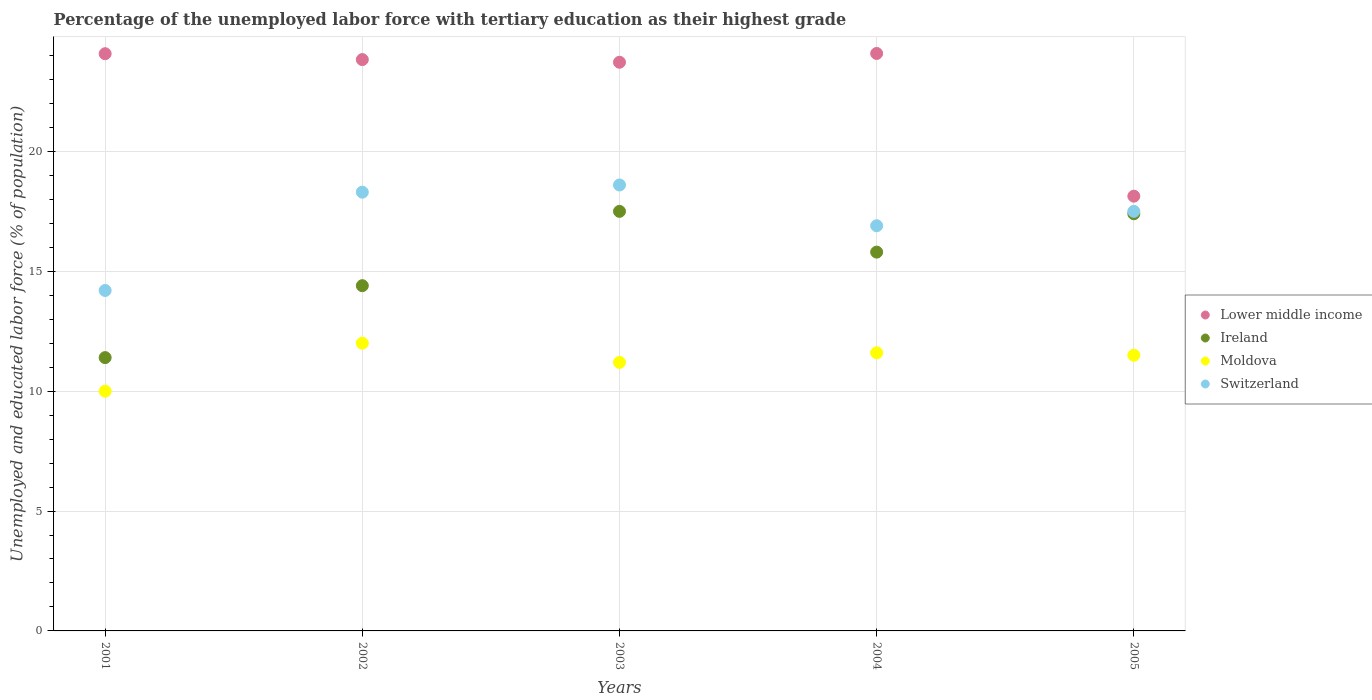How many different coloured dotlines are there?
Ensure brevity in your answer.  4. Is the number of dotlines equal to the number of legend labels?
Ensure brevity in your answer.  Yes. What is the percentage of the unemployed labor force with tertiary education in Lower middle income in 2002?
Provide a succinct answer. 23.83. Across all years, what is the maximum percentage of the unemployed labor force with tertiary education in Lower middle income?
Provide a succinct answer. 24.09. Across all years, what is the minimum percentage of the unemployed labor force with tertiary education in Lower middle income?
Your response must be concise. 18.13. In which year was the percentage of the unemployed labor force with tertiary education in Switzerland maximum?
Make the answer very short. 2003. In which year was the percentage of the unemployed labor force with tertiary education in Ireland minimum?
Your response must be concise. 2001. What is the total percentage of the unemployed labor force with tertiary education in Moldova in the graph?
Offer a very short reply. 56.3. What is the difference between the percentage of the unemployed labor force with tertiary education in Ireland in 2001 and that in 2005?
Ensure brevity in your answer.  -6. What is the difference between the percentage of the unemployed labor force with tertiary education in Moldova in 2001 and the percentage of the unemployed labor force with tertiary education in Ireland in 2005?
Offer a terse response. -7.4. What is the average percentage of the unemployed labor force with tertiary education in Switzerland per year?
Your answer should be very brief. 17.1. In the year 2002, what is the difference between the percentage of the unemployed labor force with tertiary education in Lower middle income and percentage of the unemployed labor force with tertiary education in Switzerland?
Your answer should be very brief. 5.53. What is the ratio of the percentage of the unemployed labor force with tertiary education in Switzerland in 2002 to that in 2004?
Make the answer very short. 1.08. What is the difference between the highest and the second highest percentage of the unemployed labor force with tertiary education in Moldova?
Make the answer very short. 0.4. What is the difference between the highest and the lowest percentage of the unemployed labor force with tertiary education in Switzerland?
Provide a succinct answer. 4.4. In how many years, is the percentage of the unemployed labor force with tertiary education in Lower middle income greater than the average percentage of the unemployed labor force with tertiary education in Lower middle income taken over all years?
Give a very brief answer. 4. Is the sum of the percentage of the unemployed labor force with tertiary education in Moldova in 2001 and 2005 greater than the maximum percentage of the unemployed labor force with tertiary education in Ireland across all years?
Provide a succinct answer. Yes. Is it the case that in every year, the sum of the percentage of the unemployed labor force with tertiary education in Lower middle income and percentage of the unemployed labor force with tertiary education in Switzerland  is greater than the sum of percentage of the unemployed labor force with tertiary education in Ireland and percentage of the unemployed labor force with tertiary education in Moldova?
Make the answer very short. Yes. What is the difference between two consecutive major ticks on the Y-axis?
Offer a very short reply. 5. Where does the legend appear in the graph?
Keep it short and to the point. Center right. How many legend labels are there?
Your answer should be compact. 4. How are the legend labels stacked?
Make the answer very short. Vertical. What is the title of the graph?
Give a very brief answer. Percentage of the unemployed labor force with tertiary education as their highest grade. What is the label or title of the Y-axis?
Offer a terse response. Unemployed and educated labor force (% of population). What is the Unemployed and educated labor force (% of population) of Lower middle income in 2001?
Keep it short and to the point. 24.08. What is the Unemployed and educated labor force (% of population) in Ireland in 2001?
Keep it short and to the point. 11.4. What is the Unemployed and educated labor force (% of population) in Switzerland in 2001?
Your answer should be compact. 14.2. What is the Unemployed and educated labor force (% of population) in Lower middle income in 2002?
Provide a short and direct response. 23.83. What is the Unemployed and educated labor force (% of population) of Ireland in 2002?
Keep it short and to the point. 14.4. What is the Unemployed and educated labor force (% of population) in Moldova in 2002?
Make the answer very short. 12. What is the Unemployed and educated labor force (% of population) of Switzerland in 2002?
Your response must be concise. 18.3. What is the Unemployed and educated labor force (% of population) in Lower middle income in 2003?
Ensure brevity in your answer.  23.72. What is the Unemployed and educated labor force (% of population) of Moldova in 2003?
Your answer should be compact. 11.2. What is the Unemployed and educated labor force (% of population) in Switzerland in 2003?
Your response must be concise. 18.6. What is the Unemployed and educated labor force (% of population) of Lower middle income in 2004?
Give a very brief answer. 24.09. What is the Unemployed and educated labor force (% of population) of Ireland in 2004?
Ensure brevity in your answer.  15.8. What is the Unemployed and educated labor force (% of population) of Moldova in 2004?
Your answer should be very brief. 11.6. What is the Unemployed and educated labor force (% of population) in Switzerland in 2004?
Offer a terse response. 16.9. What is the Unemployed and educated labor force (% of population) of Lower middle income in 2005?
Your answer should be compact. 18.13. What is the Unemployed and educated labor force (% of population) in Ireland in 2005?
Ensure brevity in your answer.  17.4. What is the Unemployed and educated labor force (% of population) in Moldova in 2005?
Make the answer very short. 11.5. What is the Unemployed and educated labor force (% of population) of Switzerland in 2005?
Keep it short and to the point. 17.5. Across all years, what is the maximum Unemployed and educated labor force (% of population) of Lower middle income?
Offer a terse response. 24.09. Across all years, what is the maximum Unemployed and educated labor force (% of population) of Moldova?
Your response must be concise. 12. Across all years, what is the maximum Unemployed and educated labor force (% of population) in Switzerland?
Provide a short and direct response. 18.6. Across all years, what is the minimum Unemployed and educated labor force (% of population) of Lower middle income?
Your answer should be very brief. 18.13. Across all years, what is the minimum Unemployed and educated labor force (% of population) of Ireland?
Your answer should be very brief. 11.4. Across all years, what is the minimum Unemployed and educated labor force (% of population) of Moldova?
Provide a succinct answer. 10. Across all years, what is the minimum Unemployed and educated labor force (% of population) of Switzerland?
Your answer should be compact. 14.2. What is the total Unemployed and educated labor force (% of population) in Lower middle income in the graph?
Keep it short and to the point. 113.84. What is the total Unemployed and educated labor force (% of population) in Ireland in the graph?
Ensure brevity in your answer.  76.5. What is the total Unemployed and educated labor force (% of population) in Moldova in the graph?
Provide a succinct answer. 56.3. What is the total Unemployed and educated labor force (% of population) in Switzerland in the graph?
Provide a short and direct response. 85.5. What is the difference between the Unemployed and educated labor force (% of population) in Lower middle income in 2001 and that in 2002?
Provide a succinct answer. 0.25. What is the difference between the Unemployed and educated labor force (% of population) in Moldova in 2001 and that in 2002?
Offer a very short reply. -2. What is the difference between the Unemployed and educated labor force (% of population) in Switzerland in 2001 and that in 2002?
Your answer should be compact. -4.1. What is the difference between the Unemployed and educated labor force (% of population) of Lower middle income in 2001 and that in 2003?
Give a very brief answer. 0.36. What is the difference between the Unemployed and educated labor force (% of population) of Ireland in 2001 and that in 2003?
Give a very brief answer. -6.1. What is the difference between the Unemployed and educated labor force (% of population) in Lower middle income in 2001 and that in 2004?
Ensure brevity in your answer.  -0.01. What is the difference between the Unemployed and educated labor force (% of population) of Moldova in 2001 and that in 2004?
Your answer should be compact. -1.6. What is the difference between the Unemployed and educated labor force (% of population) in Lower middle income in 2001 and that in 2005?
Your answer should be compact. 5.94. What is the difference between the Unemployed and educated labor force (% of population) in Ireland in 2001 and that in 2005?
Give a very brief answer. -6. What is the difference between the Unemployed and educated labor force (% of population) of Moldova in 2001 and that in 2005?
Your response must be concise. -1.5. What is the difference between the Unemployed and educated labor force (% of population) in Switzerland in 2001 and that in 2005?
Your response must be concise. -3.3. What is the difference between the Unemployed and educated labor force (% of population) of Lower middle income in 2002 and that in 2003?
Provide a short and direct response. 0.11. What is the difference between the Unemployed and educated labor force (% of population) of Ireland in 2002 and that in 2003?
Ensure brevity in your answer.  -3.1. What is the difference between the Unemployed and educated labor force (% of population) in Lower middle income in 2002 and that in 2004?
Give a very brief answer. -0.26. What is the difference between the Unemployed and educated labor force (% of population) in Ireland in 2002 and that in 2004?
Provide a short and direct response. -1.4. What is the difference between the Unemployed and educated labor force (% of population) of Moldova in 2002 and that in 2004?
Make the answer very short. 0.4. What is the difference between the Unemployed and educated labor force (% of population) of Lower middle income in 2002 and that in 2005?
Make the answer very short. 5.7. What is the difference between the Unemployed and educated labor force (% of population) in Switzerland in 2002 and that in 2005?
Offer a very short reply. 0.8. What is the difference between the Unemployed and educated labor force (% of population) in Lower middle income in 2003 and that in 2004?
Your answer should be very brief. -0.37. What is the difference between the Unemployed and educated labor force (% of population) of Ireland in 2003 and that in 2004?
Offer a terse response. 1.7. What is the difference between the Unemployed and educated labor force (% of population) of Moldova in 2003 and that in 2004?
Provide a short and direct response. -0.4. What is the difference between the Unemployed and educated labor force (% of population) in Lower middle income in 2003 and that in 2005?
Make the answer very short. 5.59. What is the difference between the Unemployed and educated labor force (% of population) in Moldova in 2003 and that in 2005?
Ensure brevity in your answer.  -0.3. What is the difference between the Unemployed and educated labor force (% of population) of Lower middle income in 2004 and that in 2005?
Give a very brief answer. 5.95. What is the difference between the Unemployed and educated labor force (% of population) of Moldova in 2004 and that in 2005?
Offer a very short reply. 0.1. What is the difference between the Unemployed and educated labor force (% of population) in Lower middle income in 2001 and the Unemployed and educated labor force (% of population) in Ireland in 2002?
Offer a very short reply. 9.68. What is the difference between the Unemployed and educated labor force (% of population) in Lower middle income in 2001 and the Unemployed and educated labor force (% of population) in Moldova in 2002?
Make the answer very short. 12.08. What is the difference between the Unemployed and educated labor force (% of population) in Lower middle income in 2001 and the Unemployed and educated labor force (% of population) in Switzerland in 2002?
Make the answer very short. 5.78. What is the difference between the Unemployed and educated labor force (% of population) of Ireland in 2001 and the Unemployed and educated labor force (% of population) of Moldova in 2002?
Ensure brevity in your answer.  -0.6. What is the difference between the Unemployed and educated labor force (% of population) in Ireland in 2001 and the Unemployed and educated labor force (% of population) in Switzerland in 2002?
Offer a terse response. -6.9. What is the difference between the Unemployed and educated labor force (% of population) in Moldova in 2001 and the Unemployed and educated labor force (% of population) in Switzerland in 2002?
Ensure brevity in your answer.  -8.3. What is the difference between the Unemployed and educated labor force (% of population) of Lower middle income in 2001 and the Unemployed and educated labor force (% of population) of Ireland in 2003?
Provide a short and direct response. 6.58. What is the difference between the Unemployed and educated labor force (% of population) of Lower middle income in 2001 and the Unemployed and educated labor force (% of population) of Moldova in 2003?
Your response must be concise. 12.88. What is the difference between the Unemployed and educated labor force (% of population) in Lower middle income in 2001 and the Unemployed and educated labor force (% of population) in Switzerland in 2003?
Provide a succinct answer. 5.48. What is the difference between the Unemployed and educated labor force (% of population) of Ireland in 2001 and the Unemployed and educated labor force (% of population) of Switzerland in 2003?
Give a very brief answer. -7.2. What is the difference between the Unemployed and educated labor force (% of population) of Moldova in 2001 and the Unemployed and educated labor force (% of population) of Switzerland in 2003?
Give a very brief answer. -8.6. What is the difference between the Unemployed and educated labor force (% of population) in Lower middle income in 2001 and the Unemployed and educated labor force (% of population) in Ireland in 2004?
Make the answer very short. 8.28. What is the difference between the Unemployed and educated labor force (% of population) in Lower middle income in 2001 and the Unemployed and educated labor force (% of population) in Moldova in 2004?
Offer a very short reply. 12.48. What is the difference between the Unemployed and educated labor force (% of population) of Lower middle income in 2001 and the Unemployed and educated labor force (% of population) of Switzerland in 2004?
Provide a short and direct response. 7.18. What is the difference between the Unemployed and educated labor force (% of population) in Moldova in 2001 and the Unemployed and educated labor force (% of population) in Switzerland in 2004?
Your answer should be very brief. -6.9. What is the difference between the Unemployed and educated labor force (% of population) in Lower middle income in 2001 and the Unemployed and educated labor force (% of population) in Ireland in 2005?
Keep it short and to the point. 6.68. What is the difference between the Unemployed and educated labor force (% of population) in Lower middle income in 2001 and the Unemployed and educated labor force (% of population) in Moldova in 2005?
Provide a succinct answer. 12.58. What is the difference between the Unemployed and educated labor force (% of population) of Lower middle income in 2001 and the Unemployed and educated labor force (% of population) of Switzerland in 2005?
Your response must be concise. 6.58. What is the difference between the Unemployed and educated labor force (% of population) of Ireland in 2001 and the Unemployed and educated labor force (% of population) of Switzerland in 2005?
Ensure brevity in your answer.  -6.1. What is the difference between the Unemployed and educated labor force (% of population) in Moldova in 2001 and the Unemployed and educated labor force (% of population) in Switzerland in 2005?
Make the answer very short. -7.5. What is the difference between the Unemployed and educated labor force (% of population) in Lower middle income in 2002 and the Unemployed and educated labor force (% of population) in Ireland in 2003?
Offer a very short reply. 6.33. What is the difference between the Unemployed and educated labor force (% of population) of Lower middle income in 2002 and the Unemployed and educated labor force (% of population) of Moldova in 2003?
Provide a short and direct response. 12.63. What is the difference between the Unemployed and educated labor force (% of population) in Lower middle income in 2002 and the Unemployed and educated labor force (% of population) in Switzerland in 2003?
Your answer should be compact. 5.23. What is the difference between the Unemployed and educated labor force (% of population) of Ireland in 2002 and the Unemployed and educated labor force (% of population) of Moldova in 2003?
Your answer should be compact. 3.2. What is the difference between the Unemployed and educated labor force (% of population) of Ireland in 2002 and the Unemployed and educated labor force (% of population) of Switzerland in 2003?
Offer a terse response. -4.2. What is the difference between the Unemployed and educated labor force (% of population) in Moldova in 2002 and the Unemployed and educated labor force (% of population) in Switzerland in 2003?
Ensure brevity in your answer.  -6.6. What is the difference between the Unemployed and educated labor force (% of population) in Lower middle income in 2002 and the Unemployed and educated labor force (% of population) in Ireland in 2004?
Ensure brevity in your answer.  8.03. What is the difference between the Unemployed and educated labor force (% of population) of Lower middle income in 2002 and the Unemployed and educated labor force (% of population) of Moldova in 2004?
Your response must be concise. 12.23. What is the difference between the Unemployed and educated labor force (% of population) in Lower middle income in 2002 and the Unemployed and educated labor force (% of population) in Switzerland in 2004?
Your answer should be compact. 6.93. What is the difference between the Unemployed and educated labor force (% of population) of Lower middle income in 2002 and the Unemployed and educated labor force (% of population) of Ireland in 2005?
Offer a terse response. 6.43. What is the difference between the Unemployed and educated labor force (% of population) of Lower middle income in 2002 and the Unemployed and educated labor force (% of population) of Moldova in 2005?
Provide a short and direct response. 12.33. What is the difference between the Unemployed and educated labor force (% of population) of Lower middle income in 2002 and the Unemployed and educated labor force (% of population) of Switzerland in 2005?
Offer a terse response. 6.33. What is the difference between the Unemployed and educated labor force (% of population) of Ireland in 2002 and the Unemployed and educated labor force (% of population) of Moldova in 2005?
Offer a very short reply. 2.9. What is the difference between the Unemployed and educated labor force (% of population) in Lower middle income in 2003 and the Unemployed and educated labor force (% of population) in Ireland in 2004?
Make the answer very short. 7.92. What is the difference between the Unemployed and educated labor force (% of population) of Lower middle income in 2003 and the Unemployed and educated labor force (% of population) of Moldova in 2004?
Your answer should be very brief. 12.12. What is the difference between the Unemployed and educated labor force (% of population) in Lower middle income in 2003 and the Unemployed and educated labor force (% of population) in Switzerland in 2004?
Your answer should be compact. 6.82. What is the difference between the Unemployed and educated labor force (% of population) in Ireland in 2003 and the Unemployed and educated labor force (% of population) in Moldova in 2004?
Keep it short and to the point. 5.9. What is the difference between the Unemployed and educated labor force (% of population) in Ireland in 2003 and the Unemployed and educated labor force (% of population) in Switzerland in 2004?
Make the answer very short. 0.6. What is the difference between the Unemployed and educated labor force (% of population) in Lower middle income in 2003 and the Unemployed and educated labor force (% of population) in Ireland in 2005?
Your answer should be very brief. 6.32. What is the difference between the Unemployed and educated labor force (% of population) in Lower middle income in 2003 and the Unemployed and educated labor force (% of population) in Moldova in 2005?
Your answer should be compact. 12.22. What is the difference between the Unemployed and educated labor force (% of population) of Lower middle income in 2003 and the Unemployed and educated labor force (% of population) of Switzerland in 2005?
Your answer should be compact. 6.22. What is the difference between the Unemployed and educated labor force (% of population) in Lower middle income in 2004 and the Unemployed and educated labor force (% of population) in Ireland in 2005?
Offer a terse response. 6.69. What is the difference between the Unemployed and educated labor force (% of population) of Lower middle income in 2004 and the Unemployed and educated labor force (% of population) of Moldova in 2005?
Provide a succinct answer. 12.59. What is the difference between the Unemployed and educated labor force (% of population) in Lower middle income in 2004 and the Unemployed and educated labor force (% of population) in Switzerland in 2005?
Your answer should be compact. 6.59. What is the difference between the Unemployed and educated labor force (% of population) in Ireland in 2004 and the Unemployed and educated labor force (% of population) in Moldova in 2005?
Make the answer very short. 4.3. What is the difference between the Unemployed and educated labor force (% of population) of Moldova in 2004 and the Unemployed and educated labor force (% of population) of Switzerland in 2005?
Provide a short and direct response. -5.9. What is the average Unemployed and educated labor force (% of population) in Lower middle income per year?
Keep it short and to the point. 22.77. What is the average Unemployed and educated labor force (% of population) of Moldova per year?
Your response must be concise. 11.26. In the year 2001, what is the difference between the Unemployed and educated labor force (% of population) of Lower middle income and Unemployed and educated labor force (% of population) of Ireland?
Offer a very short reply. 12.68. In the year 2001, what is the difference between the Unemployed and educated labor force (% of population) in Lower middle income and Unemployed and educated labor force (% of population) in Moldova?
Give a very brief answer. 14.08. In the year 2001, what is the difference between the Unemployed and educated labor force (% of population) of Lower middle income and Unemployed and educated labor force (% of population) of Switzerland?
Make the answer very short. 9.88. In the year 2001, what is the difference between the Unemployed and educated labor force (% of population) in Ireland and Unemployed and educated labor force (% of population) in Moldova?
Provide a short and direct response. 1.4. In the year 2002, what is the difference between the Unemployed and educated labor force (% of population) in Lower middle income and Unemployed and educated labor force (% of population) in Ireland?
Keep it short and to the point. 9.43. In the year 2002, what is the difference between the Unemployed and educated labor force (% of population) of Lower middle income and Unemployed and educated labor force (% of population) of Moldova?
Give a very brief answer. 11.83. In the year 2002, what is the difference between the Unemployed and educated labor force (% of population) of Lower middle income and Unemployed and educated labor force (% of population) of Switzerland?
Provide a succinct answer. 5.53. In the year 2002, what is the difference between the Unemployed and educated labor force (% of population) in Ireland and Unemployed and educated labor force (% of population) in Moldova?
Provide a succinct answer. 2.4. In the year 2003, what is the difference between the Unemployed and educated labor force (% of population) of Lower middle income and Unemployed and educated labor force (% of population) of Ireland?
Keep it short and to the point. 6.22. In the year 2003, what is the difference between the Unemployed and educated labor force (% of population) of Lower middle income and Unemployed and educated labor force (% of population) of Moldova?
Your answer should be very brief. 12.52. In the year 2003, what is the difference between the Unemployed and educated labor force (% of population) of Lower middle income and Unemployed and educated labor force (% of population) of Switzerland?
Ensure brevity in your answer.  5.12. In the year 2003, what is the difference between the Unemployed and educated labor force (% of population) in Ireland and Unemployed and educated labor force (% of population) in Moldova?
Make the answer very short. 6.3. In the year 2004, what is the difference between the Unemployed and educated labor force (% of population) of Lower middle income and Unemployed and educated labor force (% of population) of Ireland?
Your answer should be very brief. 8.29. In the year 2004, what is the difference between the Unemployed and educated labor force (% of population) of Lower middle income and Unemployed and educated labor force (% of population) of Moldova?
Offer a terse response. 12.49. In the year 2004, what is the difference between the Unemployed and educated labor force (% of population) of Lower middle income and Unemployed and educated labor force (% of population) of Switzerland?
Keep it short and to the point. 7.19. In the year 2004, what is the difference between the Unemployed and educated labor force (% of population) in Ireland and Unemployed and educated labor force (% of population) in Switzerland?
Offer a terse response. -1.1. In the year 2004, what is the difference between the Unemployed and educated labor force (% of population) in Moldova and Unemployed and educated labor force (% of population) in Switzerland?
Provide a short and direct response. -5.3. In the year 2005, what is the difference between the Unemployed and educated labor force (% of population) in Lower middle income and Unemployed and educated labor force (% of population) in Ireland?
Your answer should be compact. 0.73. In the year 2005, what is the difference between the Unemployed and educated labor force (% of population) of Lower middle income and Unemployed and educated labor force (% of population) of Moldova?
Your answer should be very brief. 6.63. In the year 2005, what is the difference between the Unemployed and educated labor force (% of population) of Lower middle income and Unemployed and educated labor force (% of population) of Switzerland?
Keep it short and to the point. 0.63. In the year 2005, what is the difference between the Unemployed and educated labor force (% of population) of Ireland and Unemployed and educated labor force (% of population) of Switzerland?
Your answer should be very brief. -0.1. In the year 2005, what is the difference between the Unemployed and educated labor force (% of population) of Moldova and Unemployed and educated labor force (% of population) of Switzerland?
Offer a terse response. -6. What is the ratio of the Unemployed and educated labor force (% of population) in Lower middle income in 2001 to that in 2002?
Provide a short and direct response. 1.01. What is the ratio of the Unemployed and educated labor force (% of population) in Ireland in 2001 to that in 2002?
Provide a succinct answer. 0.79. What is the ratio of the Unemployed and educated labor force (% of population) in Switzerland in 2001 to that in 2002?
Offer a terse response. 0.78. What is the ratio of the Unemployed and educated labor force (% of population) in Ireland in 2001 to that in 2003?
Offer a very short reply. 0.65. What is the ratio of the Unemployed and educated labor force (% of population) of Moldova in 2001 to that in 2003?
Keep it short and to the point. 0.89. What is the ratio of the Unemployed and educated labor force (% of population) of Switzerland in 2001 to that in 2003?
Give a very brief answer. 0.76. What is the ratio of the Unemployed and educated labor force (% of population) in Lower middle income in 2001 to that in 2004?
Provide a short and direct response. 1. What is the ratio of the Unemployed and educated labor force (% of population) of Ireland in 2001 to that in 2004?
Give a very brief answer. 0.72. What is the ratio of the Unemployed and educated labor force (% of population) in Moldova in 2001 to that in 2004?
Keep it short and to the point. 0.86. What is the ratio of the Unemployed and educated labor force (% of population) in Switzerland in 2001 to that in 2004?
Your answer should be compact. 0.84. What is the ratio of the Unemployed and educated labor force (% of population) in Lower middle income in 2001 to that in 2005?
Offer a very short reply. 1.33. What is the ratio of the Unemployed and educated labor force (% of population) in Ireland in 2001 to that in 2005?
Offer a terse response. 0.66. What is the ratio of the Unemployed and educated labor force (% of population) of Moldova in 2001 to that in 2005?
Give a very brief answer. 0.87. What is the ratio of the Unemployed and educated labor force (% of population) in Switzerland in 2001 to that in 2005?
Provide a short and direct response. 0.81. What is the ratio of the Unemployed and educated labor force (% of population) in Ireland in 2002 to that in 2003?
Provide a short and direct response. 0.82. What is the ratio of the Unemployed and educated labor force (% of population) of Moldova in 2002 to that in 2003?
Provide a succinct answer. 1.07. What is the ratio of the Unemployed and educated labor force (% of population) of Switzerland in 2002 to that in 2003?
Your answer should be very brief. 0.98. What is the ratio of the Unemployed and educated labor force (% of population) in Ireland in 2002 to that in 2004?
Provide a short and direct response. 0.91. What is the ratio of the Unemployed and educated labor force (% of population) of Moldova in 2002 to that in 2004?
Give a very brief answer. 1.03. What is the ratio of the Unemployed and educated labor force (% of population) in Switzerland in 2002 to that in 2004?
Your answer should be very brief. 1.08. What is the ratio of the Unemployed and educated labor force (% of population) of Lower middle income in 2002 to that in 2005?
Provide a short and direct response. 1.31. What is the ratio of the Unemployed and educated labor force (% of population) in Ireland in 2002 to that in 2005?
Your answer should be compact. 0.83. What is the ratio of the Unemployed and educated labor force (% of population) in Moldova in 2002 to that in 2005?
Ensure brevity in your answer.  1.04. What is the ratio of the Unemployed and educated labor force (% of population) of Switzerland in 2002 to that in 2005?
Your answer should be compact. 1.05. What is the ratio of the Unemployed and educated labor force (% of population) in Lower middle income in 2003 to that in 2004?
Your answer should be very brief. 0.98. What is the ratio of the Unemployed and educated labor force (% of population) of Ireland in 2003 to that in 2004?
Your response must be concise. 1.11. What is the ratio of the Unemployed and educated labor force (% of population) in Moldova in 2003 to that in 2004?
Your response must be concise. 0.97. What is the ratio of the Unemployed and educated labor force (% of population) in Switzerland in 2003 to that in 2004?
Offer a terse response. 1.1. What is the ratio of the Unemployed and educated labor force (% of population) in Lower middle income in 2003 to that in 2005?
Offer a very short reply. 1.31. What is the ratio of the Unemployed and educated labor force (% of population) in Ireland in 2003 to that in 2005?
Offer a very short reply. 1.01. What is the ratio of the Unemployed and educated labor force (% of population) in Moldova in 2003 to that in 2005?
Your answer should be compact. 0.97. What is the ratio of the Unemployed and educated labor force (% of population) in Switzerland in 2003 to that in 2005?
Your answer should be very brief. 1.06. What is the ratio of the Unemployed and educated labor force (% of population) in Lower middle income in 2004 to that in 2005?
Your answer should be very brief. 1.33. What is the ratio of the Unemployed and educated labor force (% of population) in Ireland in 2004 to that in 2005?
Offer a terse response. 0.91. What is the ratio of the Unemployed and educated labor force (% of population) in Moldova in 2004 to that in 2005?
Your answer should be very brief. 1.01. What is the ratio of the Unemployed and educated labor force (% of population) of Switzerland in 2004 to that in 2005?
Make the answer very short. 0.97. What is the difference between the highest and the second highest Unemployed and educated labor force (% of population) of Lower middle income?
Provide a succinct answer. 0.01. What is the difference between the highest and the second highest Unemployed and educated labor force (% of population) in Moldova?
Keep it short and to the point. 0.4. What is the difference between the highest and the second highest Unemployed and educated labor force (% of population) of Switzerland?
Your response must be concise. 0.3. What is the difference between the highest and the lowest Unemployed and educated labor force (% of population) in Lower middle income?
Your response must be concise. 5.95. What is the difference between the highest and the lowest Unemployed and educated labor force (% of population) in Ireland?
Make the answer very short. 6.1. What is the difference between the highest and the lowest Unemployed and educated labor force (% of population) in Switzerland?
Offer a terse response. 4.4. 